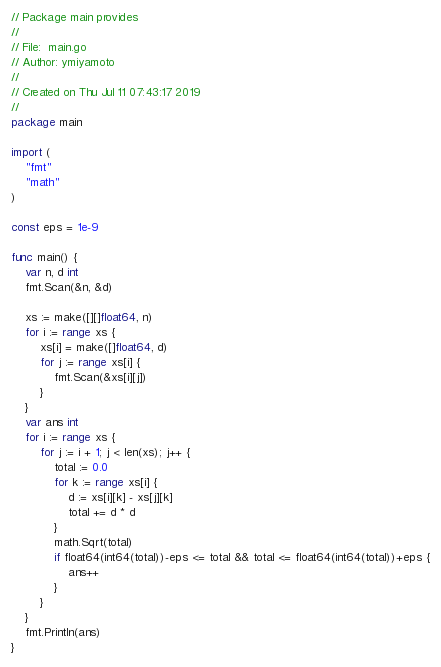Convert code to text. <code><loc_0><loc_0><loc_500><loc_500><_Go_>// Package main provides
//
// File:  main.go
// Author: ymiyamoto
//
// Created on Thu Jul 11 07:43:17 2019
//
package main

import (
	"fmt"
	"math"
)

const eps = 1e-9

func main() {
	var n, d int
	fmt.Scan(&n, &d)

	xs := make([][]float64, n)
	for i := range xs {
		xs[i] = make([]float64, d)
		for j := range xs[i] {
			fmt.Scan(&xs[i][j])
		}
	}
	var ans int
	for i := range xs {
		for j := i + 1; j < len(xs); j++ {
			total := 0.0
			for k := range xs[i] {
				d := xs[i][k] - xs[j][k]
				total += d * d
			}
			math.Sqrt(total)
			if float64(int64(total))-eps <= total && total <= float64(int64(total))+eps {
				ans++
			}
		}
	}
	fmt.Println(ans)
}
</code> 